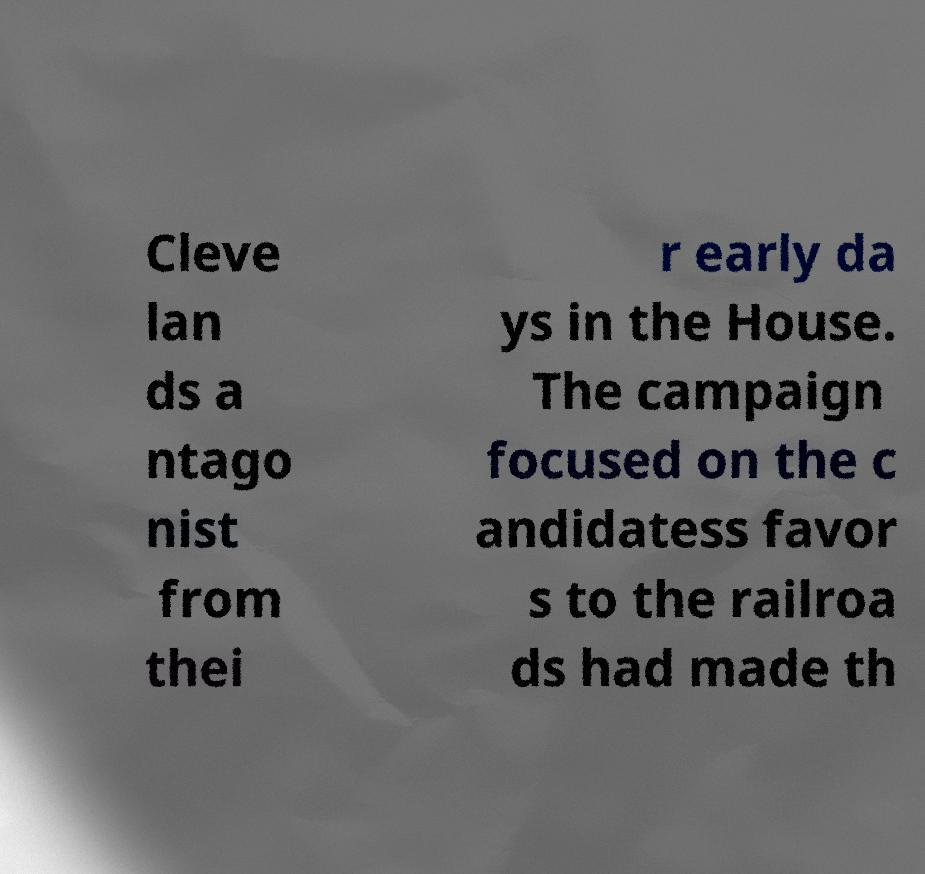What messages or text are displayed in this image? I need them in a readable, typed format. Cleve lan ds a ntago nist from thei r early da ys in the House. The campaign focused on the c andidatess favor s to the railroa ds had made th 